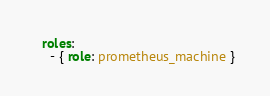Convert code to text. <code><loc_0><loc_0><loc_500><loc_500><_YAML_>  roles:
    - { role: prometheus_machine }
</code> 